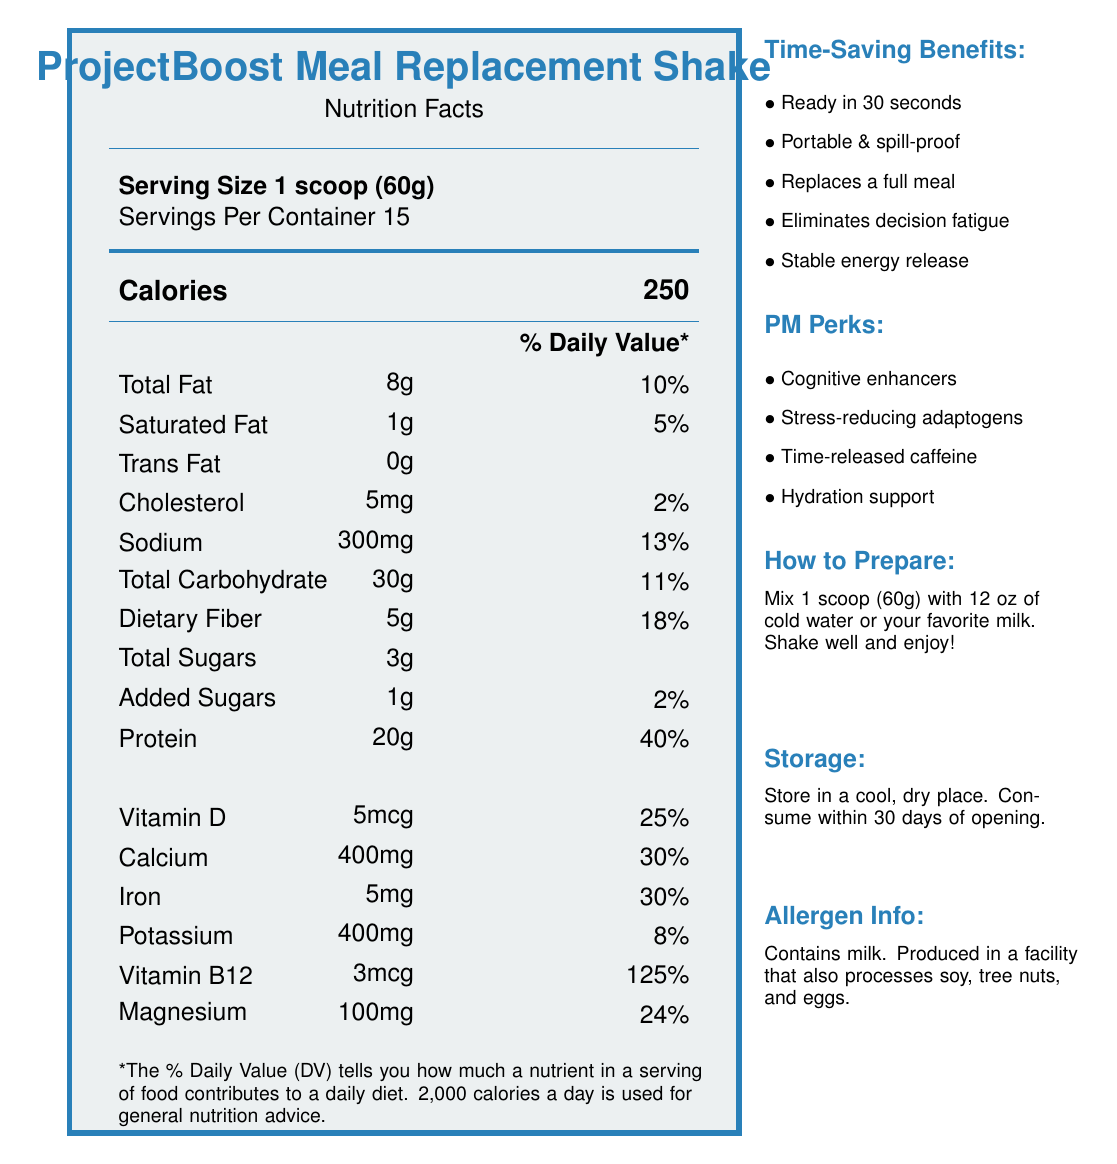what is the serving size of the ProjectBoost Meal Replacement Shake? The serving size is mentioned as "Serving Size 1 scoop (60g)" in the document.
Answer: 1 scoop (60g) how many servings are there per container? The document indicates "Servings Per Container: 15".
Answer: 15 how many calories are in each serving? The calorie content is listed as "Calories: 250".
Answer: 250 what is the total fat content per serving? The total fat content per serving is indicated as "Total Fat: 8g".
Answer: 8g how much protein does one serving contain? The document states "Protein: 20g".
Answer: 20g which vitamin has the highest daily value percentage? The daily value percentage for Vitamin B12 is 125%, which is the highest among all the vitamins and minerals listed.
Answer: Vitamin B12 what are the ingredients of the ProjectBoost Meal Replacement Shake? The ingredients are listed as per the document.
Answer: Whey protein isolate, Pea protein, Brown rice protein, Oat flour, Sunflower oil powder, Medium-chain triglycerides, Natural flavors, Xanthan gum, Stevia leaf extract, Vitamin and mineral blend how much iron is present per serving? The document states "Iron: 5mg".
Answer: 5mg Is there any trans fat in the ProjectBoost Meal Replacement Shake? The document indicates "Trans Fat: 0g".
Answer: No Does the shake contain any added sugars? The document lists "Added Sugars: 1g".
Answer: Yes how is the ProjectBoost Meal Replacement Shake prepared? The preparation instructions specify mixing and shaking.
Answer: Mix 1 scoop (60g) with 12 oz of cold water or your favorite milk. Shake well and enjoy your instant, nutritious meal. what are the storage instructions for the shake? The storage instructions state to store in a cool, dry place and consume within 30 days of opening.
Answer: Store in a cool, dry place. Consume within 30 days of opening. does this product contain milk? The allergen info states that it contains milk.
Answer: Yes what are the time-saving benefits of the ProjectBoost Shake? The document lists these time-saving benefits under the Time-Saving Benefits section.
Answer: Ready in 30 seconds, Portable and spill-proof container, Replaces a full meal, Balanced nutrition eliminates decision fatigue, Stable energy release what are the special perks for project managers provided by this product? The project manager perks are mentioned in the PM Perks section.
Answer: Cognitive enhancers, Stress-reducing adaptogens, Time-released caffeine, Electrolytes for hydration support how much Vitamin D does one serving provide? The document lists "Vitamin D: 5mcg".
Answer: 5mcg what is the total carbohydrate content per serving? The total carbohydrate content per serving is indicated as "Total Carbohydrate: 30g".
Answer: 30g which nutrient contributes 10% to the daily value per serving? A. Total Fat B. Dietary Fiber C. Calcium D. Iron The document lists the daily value of Total Fat as 10%.
Answer: A. Total Fat where is this product most likely to be useful? A. Night shifts B. Busy project managers C. High school students D. Professional athletes The product is specifically tailored with perks for busy project managers, as per the document.
Answer: B. Busy project managers are there any stress-reducing benefits in this meal replacement shake? The document mentions "Stress-reducing adaptogens" under the PM Perks section.
Answer: Yes describe the main idea of the document. The document emphasizes the shake's nutritional value and convenience features tailored for project managers, including preparation and storage instructions.
Answer: The document provides nutritional information and highlights the benefits of the ProjectBoost Meal Replacement Shake, designed for busy project managers. It includes details such as serving size, nutritional content, ingredients, allergens, time-saving benefits, and special perks geared towards project managers. how many calories come from protein per serving, assuming 4 calories per gram of protein? Each gram of protein contains 4 calories. There are 20 grams of protein per serving, thus 20g * 4 = 80 calories from protein.
Answer: 80 what is the percentage of daily value for dietary fiber? The document lists the daily value percentage for dietary fiber as 18%.
Answer: 18% is this document dated? The document does not provide any dates or time-related data.
Answer: Not enough information 